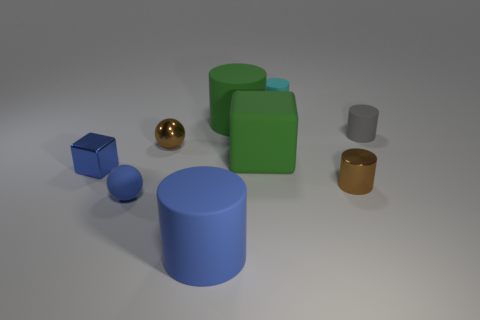Subtract all blue cylinders. How many cylinders are left? 4 Subtract all small brown metallic cylinders. How many cylinders are left? 4 Subtract all cyan cylinders. Subtract all red balls. How many cylinders are left? 4 Add 1 tiny blocks. How many objects exist? 10 Subtract all spheres. How many objects are left? 7 Subtract 0 yellow cubes. How many objects are left? 9 Subtract all tiny brown metallic spheres. Subtract all small metallic cylinders. How many objects are left? 7 Add 2 metal blocks. How many metal blocks are left? 3 Add 7 blue rubber spheres. How many blue rubber spheres exist? 8 